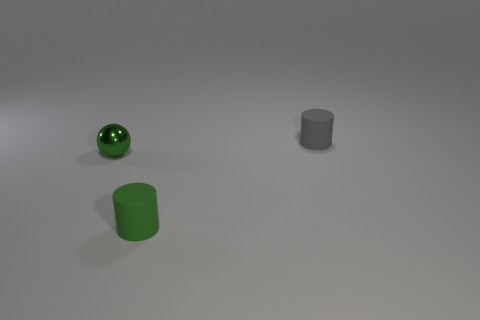Add 2 spheres. How many objects exist? 5 Subtract all gray cylinders. How many cylinders are left? 1 Subtract all cylinders. How many objects are left? 1 Subtract 1 balls. How many balls are left? 0 Add 1 green balls. How many green balls are left? 2 Add 3 green cylinders. How many green cylinders exist? 4 Subtract 1 green spheres. How many objects are left? 2 Subtract all cyan spheres. Subtract all green cubes. How many spheres are left? 1 Subtract all cyan balls. How many purple cylinders are left? 0 Subtract all large rubber blocks. Subtract all rubber cylinders. How many objects are left? 1 